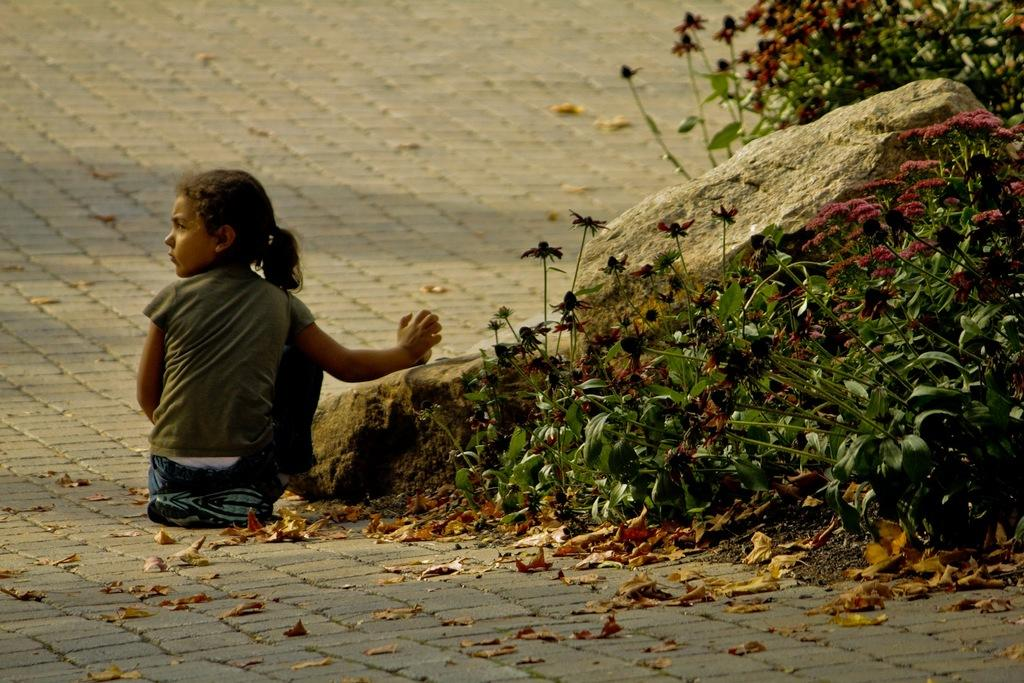What is the person in the image doing? The person is sitting on the road. What can be seen near the person? There are rocks and plants beside the person. Can you see a nest in the image? There is no nest present in the image. How many visitors are in the image? The image only shows one person, so there is only one visitor. 